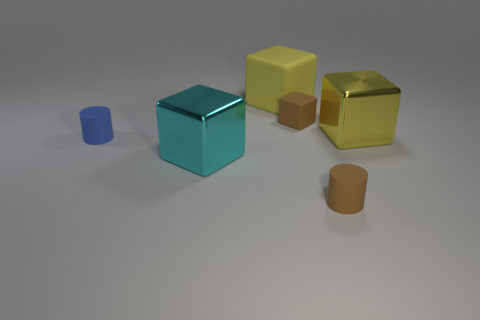The cyan thing that is the same shape as the yellow matte thing is what size?
Your answer should be very brief. Large. How many yellow blocks are the same material as the cyan block?
Your answer should be very brief. 1. What number of small blue rubber cylinders are right of the large metallic block on the right side of the brown rubber block?
Your answer should be very brief. 0. There is a cyan block; are there any small brown matte cylinders behind it?
Provide a short and direct response. No. Do the metal thing that is to the left of the tiny brown block and the large yellow rubber thing have the same shape?
Make the answer very short. Yes. What is the material of the cube that is the same color as the big matte object?
Offer a very short reply. Metal. How many rubber things are the same color as the small matte cube?
Your response must be concise. 1. What shape is the blue thing left of the tiny brown thing in front of the big cyan thing?
Offer a terse response. Cylinder. Are there any big purple matte objects that have the same shape as the blue rubber object?
Offer a terse response. No. Do the small cube and the big thing that is in front of the big yellow metal thing have the same color?
Give a very brief answer. No. 